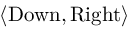Convert formula to latex. <formula><loc_0><loc_0><loc_500><loc_500>\langle { D o w n } , { R i g h t } \rangle</formula> 